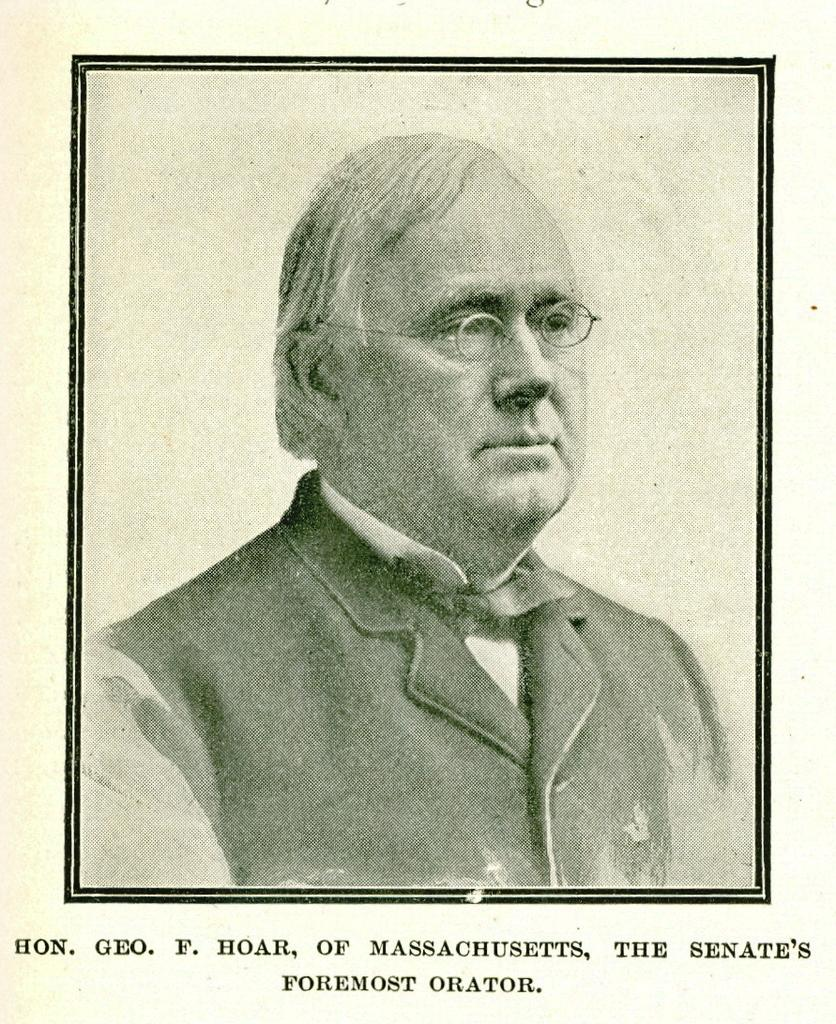What type of visual is the image? The image is a poster. Who is depicted in the poster? There is a man in the poster. What accessory is the man wearing in the image? The man is wearing spectacles. What else can be seen on the poster besides the man? There is text below the man in the poster. Is there steam coming out of the man's ears in the poster? No, there is no steam coming out of the man's ears in the poster. What type of quiver is the man holding in the poster? There is no quiver present in the poster; the man is wearing spectacles and there is text below him. 